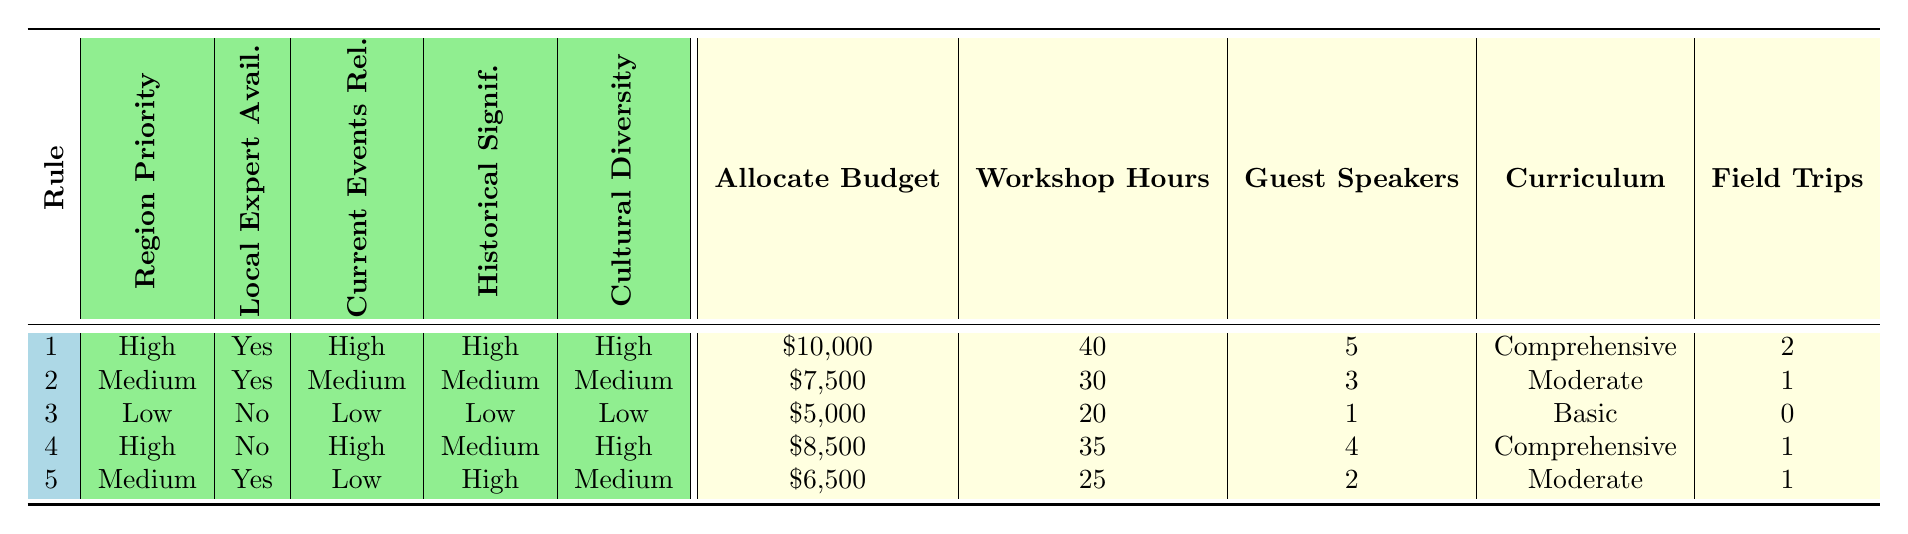What is the budget allocated for regions with a high priority and local expert availability? Referring to the table, the first rule states a budget of $10,000 for high-priority regions with local expert availability.
Answer: $10,000 How many workshop hours are assigned to mediums priority with a medium relevance of global events? Looking at the second rule, it states that medium priority with medium relevance has 30 workshop hours.
Answer: 30 Is there a guest speaker allocated for the low-priority region? In the third rule, which represents the low-priority region, it indicates there is 1 guest speaker allocated.
Answer: Yes What is the average budget for regions with high priority? The high-priority regions from the first and fourth rules allocate budgets of $10,000 and $8,500. Adding these: 10,000 + 8,500 = 18,500 and then dividing by 2 gives an average of 9,250.
Answer: $9,250 How many regions have a high cultural diversity? Referring to the rules, both high-priority regions (Middle East, Latin America) and the medium-priority region (Sub-Saharan Africa) exhibit high cultural diversity, resulting in 3 regions total (Middle East, Latin America, Sub-Saharan Africa).
Answer: 3 What is the difference in workshop hours between the high priority with local expert and high priority without local expert? The first rule states that high priority with local expert has 40 workshop hours, while the fourth rule (high priority without an expert) has 35 hours. 40 - 35 = 5 hours difference.
Answer: 5 hours Are there any low-priority regions with high historical significance? According to the table, the low-priority region, Eastern Europe, has high historical significance.
Answer: Yes How many total field trips are planned for regions with medium priority and local expert availability? The second rule allocates 1 field trip for medium priority and local expert availability. The fifth rule also shows another 1 field trip for medium priority. Adding these two: 1 + 1 gives a total of 2 field trips.
Answer: 2 field trips 